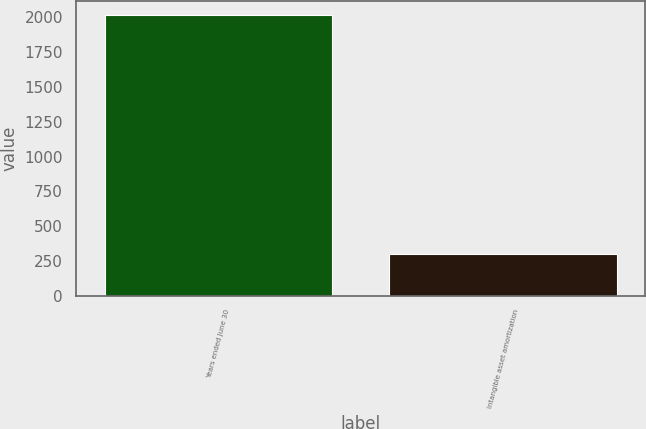<chart> <loc_0><loc_0><loc_500><loc_500><bar_chart><fcel>Years ended June 30<fcel>Intangible asset amortization<nl><fcel>2018<fcel>302<nl></chart> 